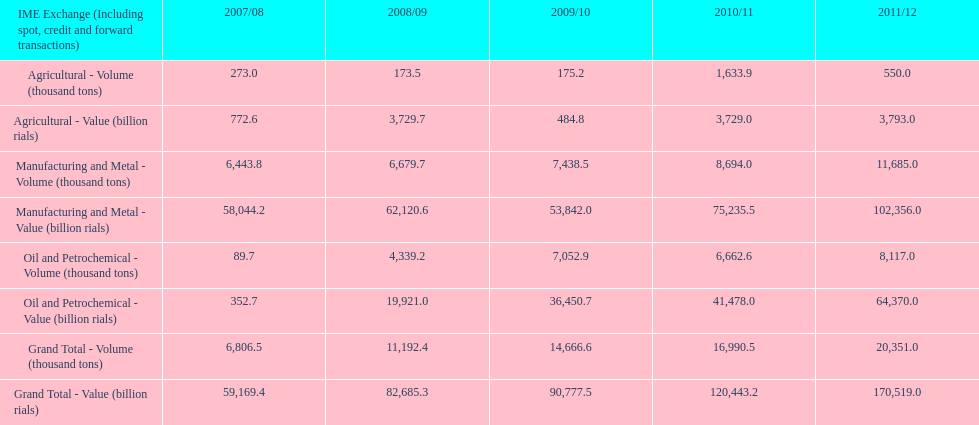What year saw the greatest value for manufacturing and metal in iran? 2011/12. 